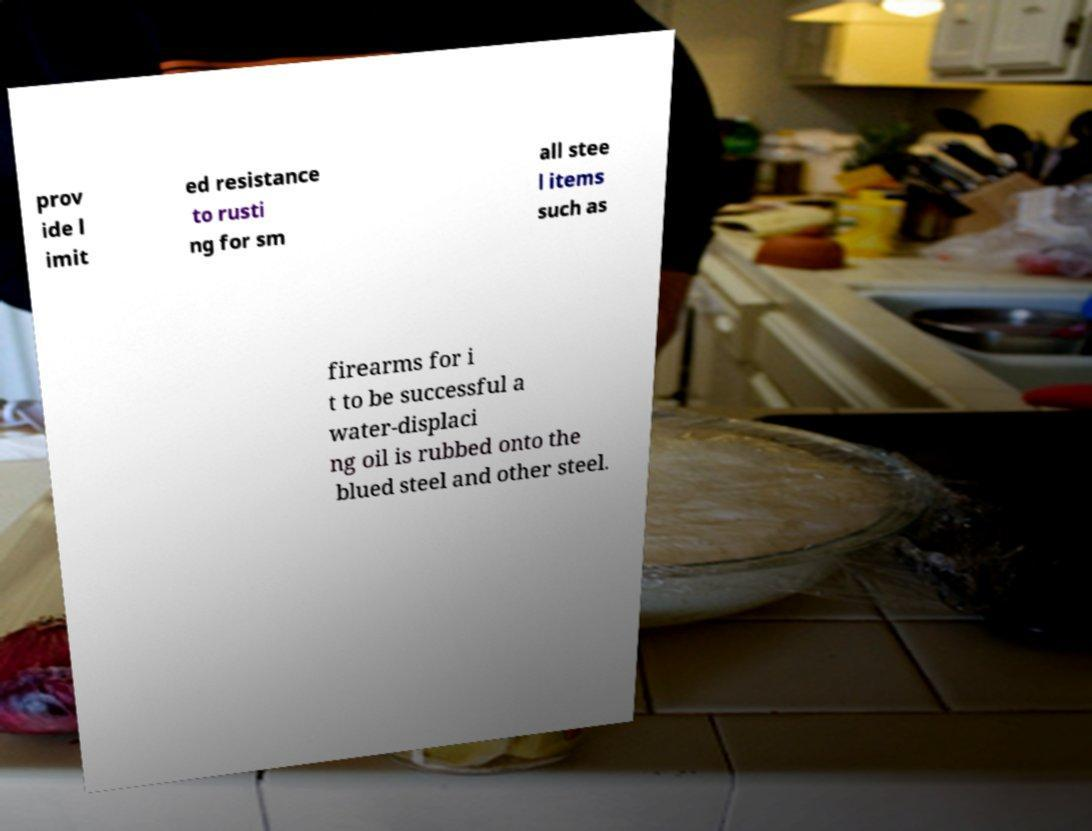Please identify and transcribe the text found in this image. prov ide l imit ed resistance to rusti ng for sm all stee l items such as firearms for i t to be successful a water-displaci ng oil is rubbed onto the blued steel and other steel. 